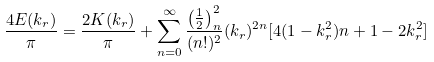<formula> <loc_0><loc_0><loc_500><loc_500>\frac { 4 E ( k _ { r } ) } { \pi } = \frac { 2 K ( k _ { r } ) } { \pi } + \sum ^ { \infty } _ { n = 0 } \frac { \left ( \frac { 1 } { 2 } \right ) ^ { 2 } _ { n } } { ( n ! ) ^ { 2 } } ( k _ { r } ) ^ { 2 n } [ 4 ( 1 - k ^ { 2 } _ { r } ) n + 1 - 2 k ^ { 2 } _ { r } ]</formula> 